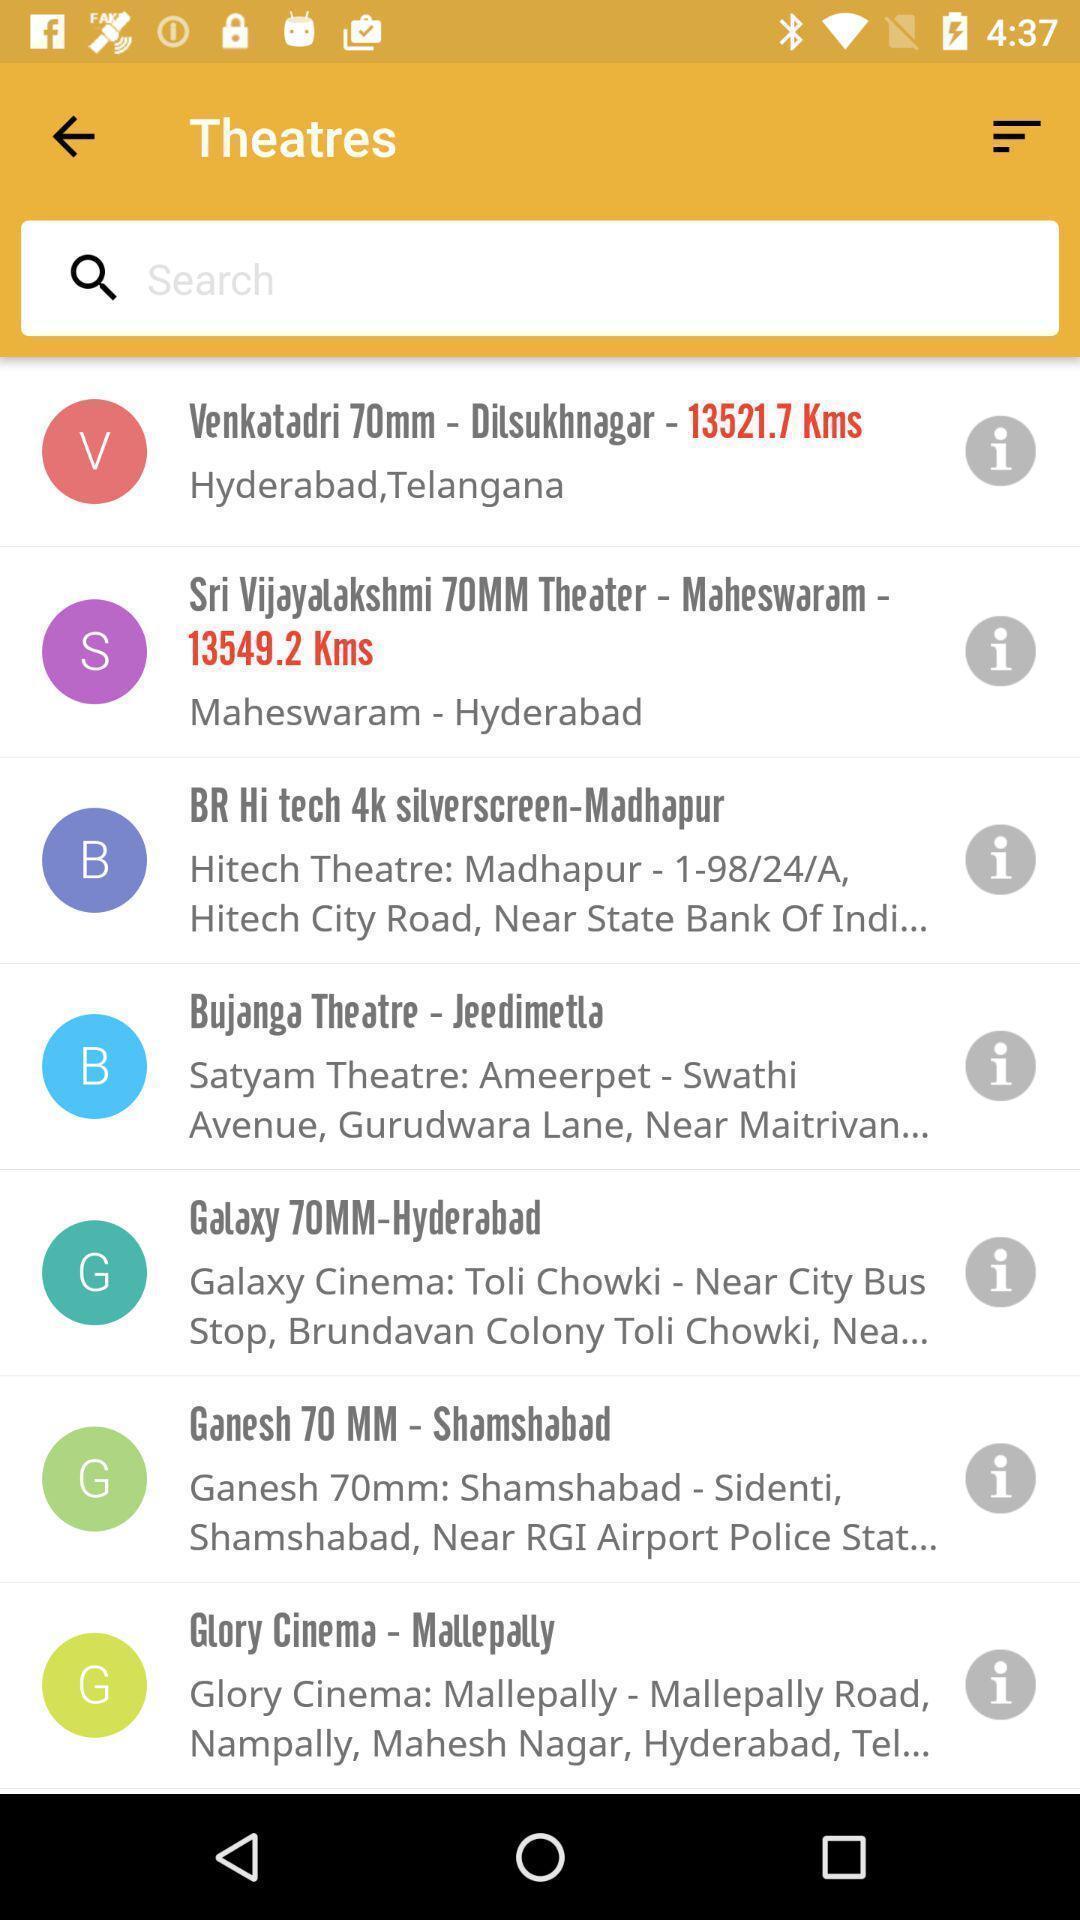Describe the content in this image. Search bar to find a theatre. 